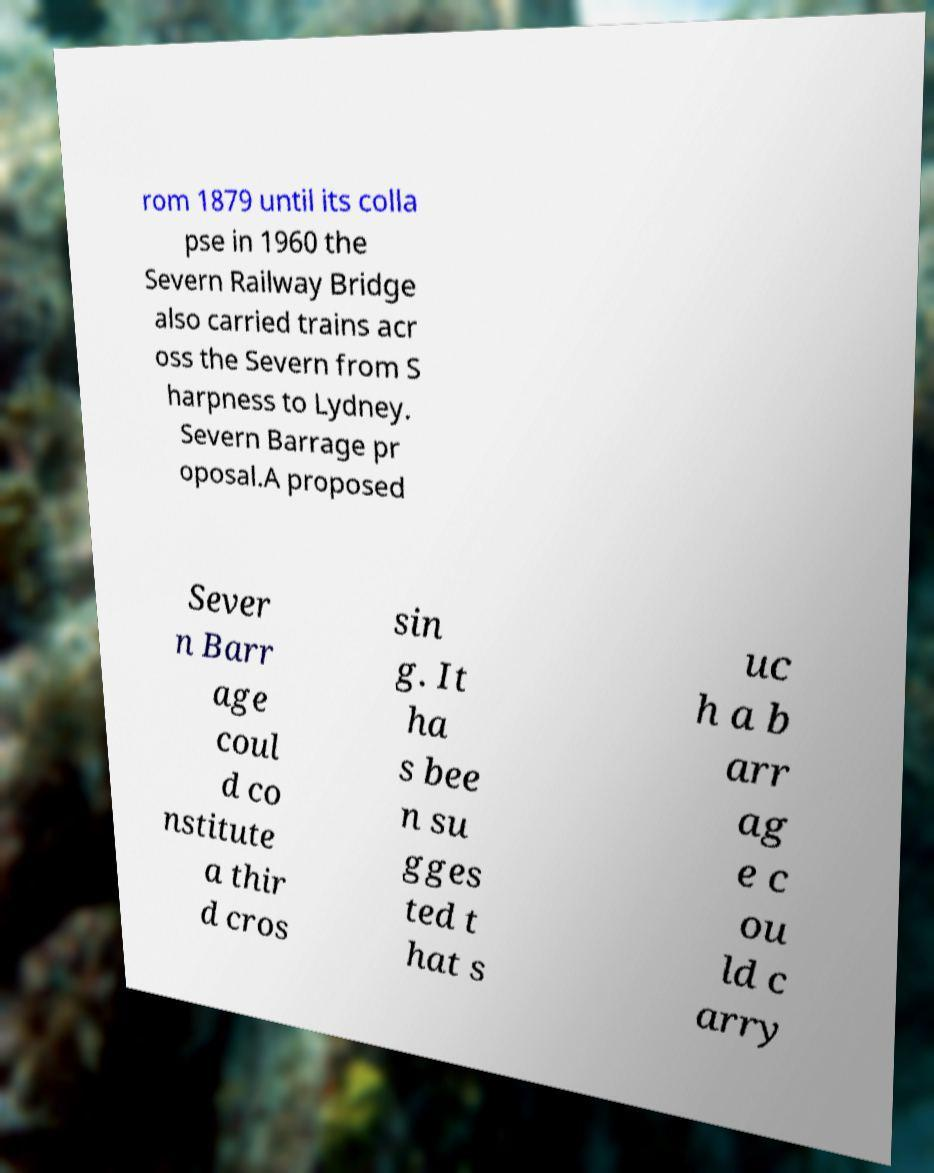For documentation purposes, I need the text within this image transcribed. Could you provide that? rom 1879 until its colla pse in 1960 the Severn Railway Bridge also carried trains acr oss the Severn from S harpness to Lydney. Severn Barrage pr oposal.A proposed Sever n Barr age coul d co nstitute a thir d cros sin g. It ha s bee n su gges ted t hat s uc h a b arr ag e c ou ld c arry 